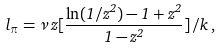<formula> <loc_0><loc_0><loc_500><loc_500>l _ { \pi } = { \nu } \, z [ \frac { \ln ( 1 / z ^ { 2 } ) - 1 + z ^ { 2 } } { 1 - z ^ { 2 } } ] \, / k \, ,</formula> 